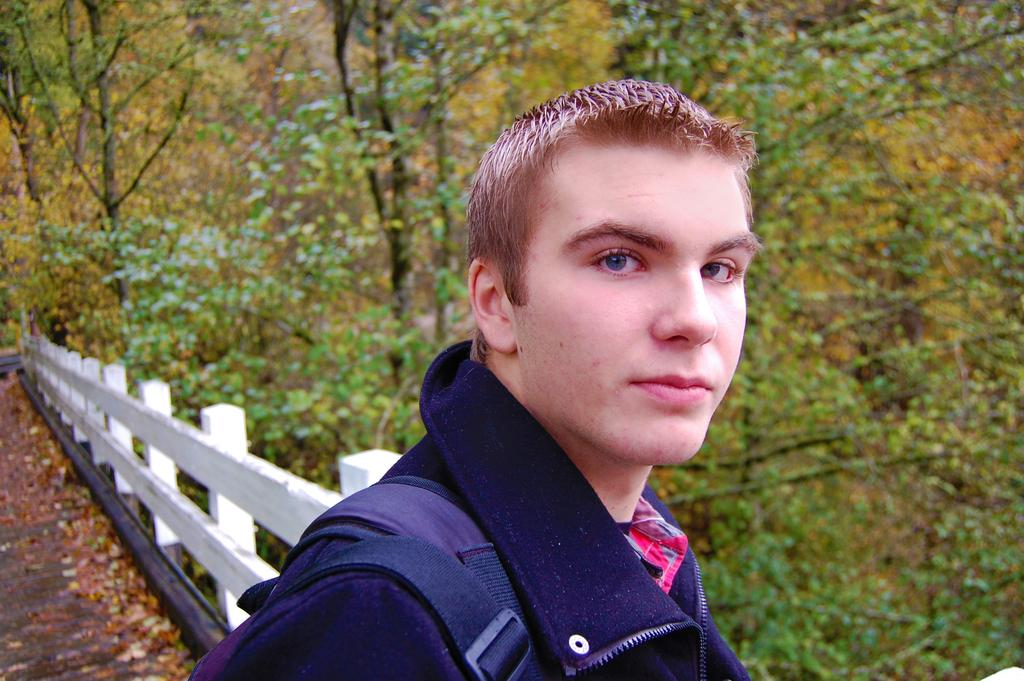What is present in the image? There is a person in the image. What can be seen in the background of the image? There is a fence and trees in the background of the image. What type of veil is the person wearing in the image? There is no veil present in the image. Is there a bomb visible in the image? No, there is no bomb present in the image. 